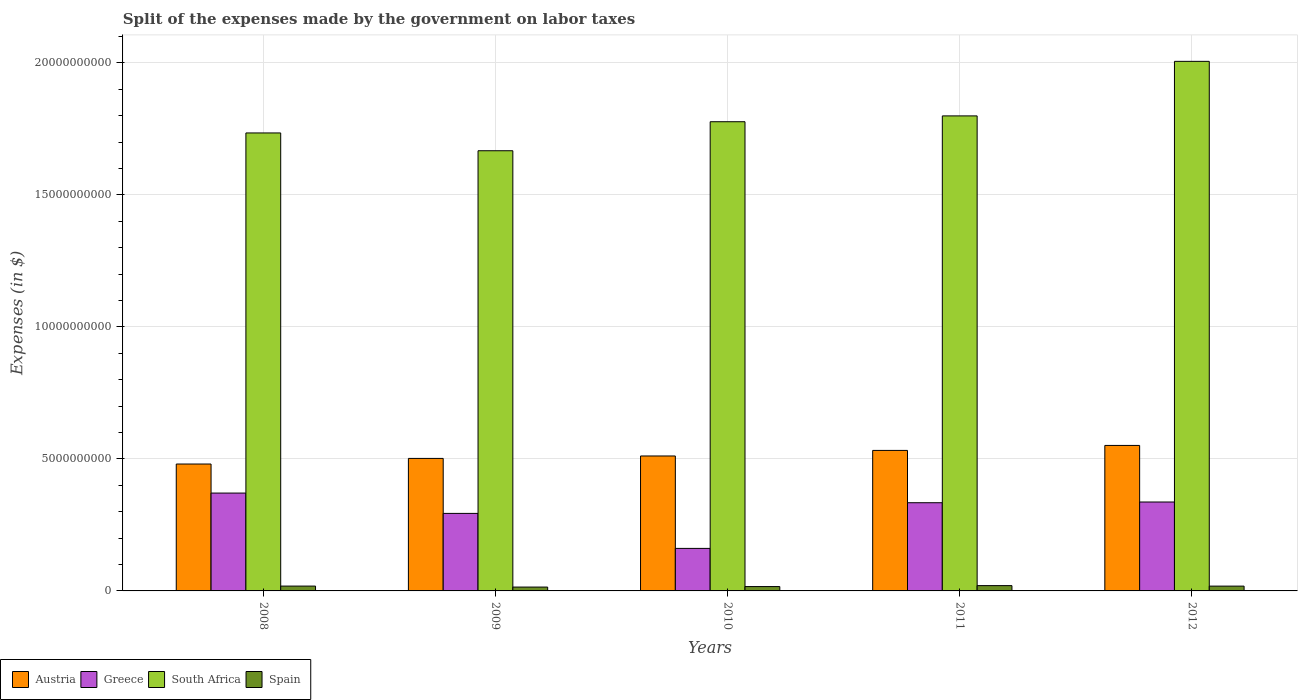How many groups of bars are there?
Keep it short and to the point. 5. Are the number of bars per tick equal to the number of legend labels?
Keep it short and to the point. Yes. Are the number of bars on each tick of the X-axis equal?
Provide a short and direct response. Yes. How many bars are there on the 5th tick from the left?
Provide a short and direct response. 4. How many bars are there on the 1st tick from the right?
Give a very brief answer. 4. What is the label of the 3rd group of bars from the left?
Offer a very short reply. 2010. In how many cases, is the number of bars for a given year not equal to the number of legend labels?
Give a very brief answer. 0. What is the expenses made by the government on labor taxes in Austria in 2009?
Your response must be concise. 5.02e+09. Across all years, what is the maximum expenses made by the government on labor taxes in Spain?
Your answer should be very brief. 2.01e+08. Across all years, what is the minimum expenses made by the government on labor taxes in Greece?
Offer a very short reply. 1.61e+09. In which year was the expenses made by the government on labor taxes in Austria maximum?
Ensure brevity in your answer.  2012. What is the total expenses made by the government on labor taxes in Spain in the graph?
Provide a short and direct response. 8.77e+08. What is the difference between the expenses made by the government on labor taxes in South Africa in 2010 and the expenses made by the government on labor taxes in Greece in 2009?
Offer a very short reply. 1.48e+1. What is the average expenses made by the government on labor taxes in South Africa per year?
Offer a very short reply. 1.80e+1. In the year 2008, what is the difference between the expenses made by the government on labor taxes in Spain and expenses made by the government on labor taxes in Greece?
Your answer should be compact. -3.52e+09. What is the ratio of the expenses made by the government on labor taxes in South Africa in 2009 to that in 2011?
Give a very brief answer. 0.93. Is the expenses made by the government on labor taxes in South Africa in 2011 less than that in 2012?
Your answer should be compact. Yes. What is the difference between the highest and the second highest expenses made by the government on labor taxes in Greece?
Keep it short and to the point. 3.39e+08. What is the difference between the highest and the lowest expenses made by the government on labor taxes in South Africa?
Your answer should be very brief. 3.39e+09. In how many years, is the expenses made by the government on labor taxes in Spain greater than the average expenses made by the government on labor taxes in Spain taken over all years?
Make the answer very short. 3. Is the sum of the expenses made by the government on labor taxes in South Africa in 2008 and 2012 greater than the maximum expenses made by the government on labor taxes in Spain across all years?
Your answer should be very brief. Yes. Is it the case that in every year, the sum of the expenses made by the government on labor taxes in Austria and expenses made by the government on labor taxes in South Africa is greater than the sum of expenses made by the government on labor taxes in Greece and expenses made by the government on labor taxes in Spain?
Offer a terse response. Yes. What does the 2nd bar from the left in 2008 represents?
Provide a short and direct response. Greece. What does the 4th bar from the right in 2010 represents?
Provide a short and direct response. Austria. Is it the case that in every year, the sum of the expenses made by the government on labor taxes in South Africa and expenses made by the government on labor taxes in Spain is greater than the expenses made by the government on labor taxes in Austria?
Make the answer very short. Yes. How many bars are there?
Offer a very short reply. 20. Are the values on the major ticks of Y-axis written in scientific E-notation?
Offer a very short reply. No. Does the graph contain grids?
Provide a succinct answer. Yes. Where does the legend appear in the graph?
Give a very brief answer. Bottom left. How are the legend labels stacked?
Your answer should be very brief. Horizontal. What is the title of the graph?
Give a very brief answer. Split of the expenses made by the government on labor taxes. Does "China" appear as one of the legend labels in the graph?
Offer a terse response. No. What is the label or title of the Y-axis?
Offer a very short reply. Expenses (in $). What is the Expenses (in $) of Austria in 2008?
Keep it short and to the point. 4.81e+09. What is the Expenses (in $) of Greece in 2008?
Offer a terse response. 3.71e+09. What is the Expenses (in $) in South Africa in 2008?
Offer a very short reply. 1.73e+1. What is the Expenses (in $) of Spain in 2008?
Provide a short and direct response. 1.83e+08. What is the Expenses (in $) of Austria in 2009?
Ensure brevity in your answer.  5.02e+09. What is the Expenses (in $) of Greece in 2009?
Give a very brief answer. 2.94e+09. What is the Expenses (in $) in South Africa in 2009?
Offer a terse response. 1.67e+1. What is the Expenses (in $) of Spain in 2009?
Give a very brief answer. 1.46e+08. What is the Expenses (in $) in Austria in 2010?
Ensure brevity in your answer.  5.11e+09. What is the Expenses (in $) of Greece in 2010?
Offer a terse response. 1.61e+09. What is the Expenses (in $) in South Africa in 2010?
Give a very brief answer. 1.78e+1. What is the Expenses (in $) of Spain in 2010?
Give a very brief answer. 1.65e+08. What is the Expenses (in $) of Austria in 2011?
Keep it short and to the point. 5.32e+09. What is the Expenses (in $) of Greece in 2011?
Provide a short and direct response. 3.34e+09. What is the Expenses (in $) of South Africa in 2011?
Your answer should be compact. 1.80e+1. What is the Expenses (in $) in Spain in 2011?
Offer a terse response. 2.01e+08. What is the Expenses (in $) in Austria in 2012?
Provide a succinct answer. 5.51e+09. What is the Expenses (in $) in Greece in 2012?
Offer a very short reply. 3.37e+09. What is the Expenses (in $) in South Africa in 2012?
Make the answer very short. 2.01e+1. What is the Expenses (in $) in Spain in 2012?
Your answer should be compact. 1.82e+08. Across all years, what is the maximum Expenses (in $) in Austria?
Ensure brevity in your answer.  5.51e+09. Across all years, what is the maximum Expenses (in $) in Greece?
Offer a very short reply. 3.71e+09. Across all years, what is the maximum Expenses (in $) of South Africa?
Your response must be concise. 2.01e+1. Across all years, what is the maximum Expenses (in $) of Spain?
Offer a terse response. 2.01e+08. Across all years, what is the minimum Expenses (in $) in Austria?
Your answer should be compact. 4.81e+09. Across all years, what is the minimum Expenses (in $) in Greece?
Make the answer very short. 1.61e+09. Across all years, what is the minimum Expenses (in $) in South Africa?
Make the answer very short. 1.67e+1. Across all years, what is the minimum Expenses (in $) of Spain?
Your answer should be compact. 1.46e+08. What is the total Expenses (in $) in Austria in the graph?
Your answer should be compact. 2.58e+1. What is the total Expenses (in $) in Greece in the graph?
Your response must be concise. 1.50e+1. What is the total Expenses (in $) of South Africa in the graph?
Keep it short and to the point. 8.99e+1. What is the total Expenses (in $) of Spain in the graph?
Ensure brevity in your answer.  8.77e+08. What is the difference between the Expenses (in $) in Austria in 2008 and that in 2009?
Make the answer very short. -2.13e+08. What is the difference between the Expenses (in $) of Greece in 2008 and that in 2009?
Provide a short and direct response. 7.70e+08. What is the difference between the Expenses (in $) in South Africa in 2008 and that in 2009?
Provide a short and direct response. 6.74e+08. What is the difference between the Expenses (in $) of Spain in 2008 and that in 2009?
Make the answer very short. 3.70e+07. What is the difference between the Expenses (in $) in Austria in 2008 and that in 2010?
Your answer should be compact. -3.05e+08. What is the difference between the Expenses (in $) of Greece in 2008 and that in 2010?
Offer a terse response. 2.10e+09. What is the difference between the Expenses (in $) in South Africa in 2008 and that in 2010?
Provide a short and direct response. -4.25e+08. What is the difference between the Expenses (in $) in Spain in 2008 and that in 2010?
Your answer should be compact. 1.80e+07. What is the difference between the Expenses (in $) of Austria in 2008 and that in 2011?
Make the answer very short. -5.16e+08. What is the difference between the Expenses (in $) of Greece in 2008 and that in 2011?
Offer a terse response. 3.66e+08. What is the difference between the Expenses (in $) in South Africa in 2008 and that in 2011?
Provide a short and direct response. -6.46e+08. What is the difference between the Expenses (in $) of Spain in 2008 and that in 2011?
Make the answer very short. -1.80e+07. What is the difference between the Expenses (in $) of Austria in 2008 and that in 2012?
Offer a terse response. -7.04e+08. What is the difference between the Expenses (in $) in Greece in 2008 and that in 2012?
Ensure brevity in your answer.  3.39e+08. What is the difference between the Expenses (in $) in South Africa in 2008 and that in 2012?
Give a very brief answer. -2.71e+09. What is the difference between the Expenses (in $) in Spain in 2008 and that in 2012?
Make the answer very short. 1.00e+06. What is the difference between the Expenses (in $) in Austria in 2009 and that in 2010?
Make the answer very short. -9.23e+07. What is the difference between the Expenses (in $) in Greece in 2009 and that in 2010?
Provide a succinct answer. 1.33e+09. What is the difference between the Expenses (in $) of South Africa in 2009 and that in 2010?
Offer a very short reply. -1.10e+09. What is the difference between the Expenses (in $) of Spain in 2009 and that in 2010?
Provide a short and direct response. -1.90e+07. What is the difference between the Expenses (in $) of Austria in 2009 and that in 2011?
Give a very brief answer. -3.03e+08. What is the difference between the Expenses (in $) of Greece in 2009 and that in 2011?
Give a very brief answer. -4.04e+08. What is the difference between the Expenses (in $) of South Africa in 2009 and that in 2011?
Ensure brevity in your answer.  -1.32e+09. What is the difference between the Expenses (in $) in Spain in 2009 and that in 2011?
Ensure brevity in your answer.  -5.50e+07. What is the difference between the Expenses (in $) of Austria in 2009 and that in 2012?
Offer a terse response. -4.92e+08. What is the difference between the Expenses (in $) of Greece in 2009 and that in 2012?
Offer a very short reply. -4.31e+08. What is the difference between the Expenses (in $) in South Africa in 2009 and that in 2012?
Provide a short and direct response. -3.39e+09. What is the difference between the Expenses (in $) of Spain in 2009 and that in 2012?
Your answer should be compact. -3.60e+07. What is the difference between the Expenses (in $) in Austria in 2010 and that in 2011?
Keep it short and to the point. -2.11e+08. What is the difference between the Expenses (in $) of Greece in 2010 and that in 2011?
Ensure brevity in your answer.  -1.73e+09. What is the difference between the Expenses (in $) of South Africa in 2010 and that in 2011?
Provide a short and direct response. -2.21e+08. What is the difference between the Expenses (in $) of Spain in 2010 and that in 2011?
Offer a terse response. -3.60e+07. What is the difference between the Expenses (in $) in Austria in 2010 and that in 2012?
Give a very brief answer. -3.99e+08. What is the difference between the Expenses (in $) in Greece in 2010 and that in 2012?
Give a very brief answer. -1.76e+09. What is the difference between the Expenses (in $) in South Africa in 2010 and that in 2012?
Offer a very short reply. -2.29e+09. What is the difference between the Expenses (in $) in Spain in 2010 and that in 2012?
Offer a terse response. -1.70e+07. What is the difference between the Expenses (in $) of Austria in 2011 and that in 2012?
Provide a short and direct response. -1.88e+08. What is the difference between the Expenses (in $) in Greece in 2011 and that in 2012?
Provide a short and direct response. -2.70e+07. What is the difference between the Expenses (in $) in South Africa in 2011 and that in 2012?
Provide a short and direct response. -2.07e+09. What is the difference between the Expenses (in $) of Spain in 2011 and that in 2012?
Offer a very short reply. 1.90e+07. What is the difference between the Expenses (in $) of Austria in 2008 and the Expenses (in $) of Greece in 2009?
Offer a terse response. 1.87e+09. What is the difference between the Expenses (in $) of Austria in 2008 and the Expenses (in $) of South Africa in 2009?
Your answer should be compact. -1.19e+1. What is the difference between the Expenses (in $) in Austria in 2008 and the Expenses (in $) in Spain in 2009?
Make the answer very short. 4.66e+09. What is the difference between the Expenses (in $) in Greece in 2008 and the Expenses (in $) in South Africa in 2009?
Provide a succinct answer. -1.30e+1. What is the difference between the Expenses (in $) in Greece in 2008 and the Expenses (in $) in Spain in 2009?
Provide a succinct answer. 3.56e+09. What is the difference between the Expenses (in $) of South Africa in 2008 and the Expenses (in $) of Spain in 2009?
Provide a short and direct response. 1.72e+1. What is the difference between the Expenses (in $) in Austria in 2008 and the Expenses (in $) in Greece in 2010?
Offer a very short reply. 3.20e+09. What is the difference between the Expenses (in $) in Austria in 2008 and the Expenses (in $) in South Africa in 2010?
Your answer should be very brief. -1.30e+1. What is the difference between the Expenses (in $) in Austria in 2008 and the Expenses (in $) in Spain in 2010?
Provide a short and direct response. 4.64e+09. What is the difference between the Expenses (in $) in Greece in 2008 and the Expenses (in $) in South Africa in 2010?
Give a very brief answer. -1.41e+1. What is the difference between the Expenses (in $) in Greece in 2008 and the Expenses (in $) in Spain in 2010?
Your response must be concise. 3.54e+09. What is the difference between the Expenses (in $) in South Africa in 2008 and the Expenses (in $) in Spain in 2010?
Provide a short and direct response. 1.72e+1. What is the difference between the Expenses (in $) of Austria in 2008 and the Expenses (in $) of Greece in 2011?
Keep it short and to the point. 1.47e+09. What is the difference between the Expenses (in $) in Austria in 2008 and the Expenses (in $) in South Africa in 2011?
Keep it short and to the point. -1.32e+1. What is the difference between the Expenses (in $) of Austria in 2008 and the Expenses (in $) of Spain in 2011?
Your answer should be compact. 4.61e+09. What is the difference between the Expenses (in $) in Greece in 2008 and the Expenses (in $) in South Africa in 2011?
Keep it short and to the point. -1.43e+1. What is the difference between the Expenses (in $) in Greece in 2008 and the Expenses (in $) in Spain in 2011?
Offer a very short reply. 3.51e+09. What is the difference between the Expenses (in $) of South Africa in 2008 and the Expenses (in $) of Spain in 2011?
Your answer should be very brief. 1.71e+1. What is the difference between the Expenses (in $) in Austria in 2008 and the Expenses (in $) in Greece in 2012?
Your answer should be compact. 1.44e+09. What is the difference between the Expenses (in $) of Austria in 2008 and the Expenses (in $) of South Africa in 2012?
Offer a terse response. -1.53e+1. What is the difference between the Expenses (in $) in Austria in 2008 and the Expenses (in $) in Spain in 2012?
Your answer should be very brief. 4.62e+09. What is the difference between the Expenses (in $) in Greece in 2008 and the Expenses (in $) in South Africa in 2012?
Provide a short and direct response. -1.64e+1. What is the difference between the Expenses (in $) in Greece in 2008 and the Expenses (in $) in Spain in 2012?
Ensure brevity in your answer.  3.52e+09. What is the difference between the Expenses (in $) of South Africa in 2008 and the Expenses (in $) of Spain in 2012?
Give a very brief answer. 1.72e+1. What is the difference between the Expenses (in $) of Austria in 2009 and the Expenses (in $) of Greece in 2010?
Offer a very short reply. 3.41e+09. What is the difference between the Expenses (in $) in Austria in 2009 and the Expenses (in $) in South Africa in 2010?
Provide a succinct answer. -1.28e+1. What is the difference between the Expenses (in $) of Austria in 2009 and the Expenses (in $) of Spain in 2010?
Keep it short and to the point. 4.85e+09. What is the difference between the Expenses (in $) of Greece in 2009 and the Expenses (in $) of South Africa in 2010?
Your response must be concise. -1.48e+1. What is the difference between the Expenses (in $) in Greece in 2009 and the Expenses (in $) in Spain in 2010?
Give a very brief answer. 2.77e+09. What is the difference between the Expenses (in $) in South Africa in 2009 and the Expenses (in $) in Spain in 2010?
Give a very brief answer. 1.65e+1. What is the difference between the Expenses (in $) of Austria in 2009 and the Expenses (in $) of Greece in 2011?
Your answer should be very brief. 1.68e+09. What is the difference between the Expenses (in $) in Austria in 2009 and the Expenses (in $) in South Africa in 2011?
Give a very brief answer. -1.30e+1. What is the difference between the Expenses (in $) of Austria in 2009 and the Expenses (in $) of Spain in 2011?
Keep it short and to the point. 4.82e+09. What is the difference between the Expenses (in $) in Greece in 2009 and the Expenses (in $) in South Africa in 2011?
Your answer should be very brief. -1.51e+1. What is the difference between the Expenses (in $) in Greece in 2009 and the Expenses (in $) in Spain in 2011?
Offer a very short reply. 2.74e+09. What is the difference between the Expenses (in $) of South Africa in 2009 and the Expenses (in $) of Spain in 2011?
Your answer should be compact. 1.65e+1. What is the difference between the Expenses (in $) in Austria in 2009 and the Expenses (in $) in Greece in 2012?
Your answer should be compact. 1.65e+09. What is the difference between the Expenses (in $) of Austria in 2009 and the Expenses (in $) of South Africa in 2012?
Offer a very short reply. -1.50e+1. What is the difference between the Expenses (in $) of Austria in 2009 and the Expenses (in $) of Spain in 2012?
Offer a terse response. 4.84e+09. What is the difference between the Expenses (in $) in Greece in 2009 and the Expenses (in $) in South Africa in 2012?
Your answer should be compact. -1.71e+1. What is the difference between the Expenses (in $) in Greece in 2009 and the Expenses (in $) in Spain in 2012?
Make the answer very short. 2.76e+09. What is the difference between the Expenses (in $) of South Africa in 2009 and the Expenses (in $) of Spain in 2012?
Give a very brief answer. 1.65e+1. What is the difference between the Expenses (in $) in Austria in 2010 and the Expenses (in $) in Greece in 2011?
Provide a short and direct response. 1.77e+09. What is the difference between the Expenses (in $) in Austria in 2010 and the Expenses (in $) in South Africa in 2011?
Keep it short and to the point. -1.29e+1. What is the difference between the Expenses (in $) in Austria in 2010 and the Expenses (in $) in Spain in 2011?
Provide a succinct answer. 4.91e+09. What is the difference between the Expenses (in $) of Greece in 2010 and the Expenses (in $) of South Africa in 2011?
Your answer should be very brief. -1.64e+1. What is the difference between the Expenses (in $) of Greece in 2010 and the Expenses (in $) of Spain in 2011?
Make the answer very short. 1.41e+09. What is the difference between the Expenses (in $) in South Africa in 2010 and the Expenses (in $) in Spain in 2011?
Give a very brief answer. 1.76e+1. What is the difference between the Expenses (in $) of Austria in 2010 and the Expenses (in $) of Greece in 2012?
Keep it short and to the point. 1.74e+09. What is the difference between the Expenses (in $) in Austria in 2010 and the Expenses (in $) in South Africa in 2012?
Offer a very short reply. -1.49e+1. What is the difference between the Expenses (in $) in Austria in 2010 and the Expenses (in $) in Spain in 2012?
Give a very brief answer. 4.93e+09. What is the difference between the Expenses (in $) in Greece in 2010 and the Expenses (in $) in South Africa in 2012?
Keep it short and to the point. -1.85e+1. What is the difference between the Expenses (in $) of Greece in 2010 and the Expenses (in $) of Spain in 2012?
Provide a short and direct response. 1.43e+09. What is the difference between the Expenses (in $) of South Africa in 2010 and the Expenses (in $) of Spain in 2012?
Your answer should be compact. 1.76e+1. What is the difference between the Expenses (in $) of Austria in 2011 and the Expenses (in $) of Greece in 2012?
Ensure brevity in your answer.  1.95e+09. What is the difference between the Expenses (in $) in Austria in 2011 and the Expenses (in $) in South Africa in 2012?
Give a very brief answer. -1.47e+1. What is the difference between the Expenses (in $) of Austria in 2011 and the Expenses (in $) of Spain in 2012?
Your answer should be very brief. 5.14e+09. What is the difference between the Expenses (in $) in Greece in 2011 and the Expenses (in $) in South Africa in 2012?
Offer a very short reply. -1.67e+1. What is the difference between the Expenses (in $) in Greece in 2011 and the Expenses (in $) in Spain in 2012?
Your answer should be very brief. 3.16e+09. What is the difference between the Expenses (in $) in South Africa in 2011 and the Expenses (in $) in Spain in 2012?
Your response must be concise. 1.78e+1. What is the average Expenses (in $) in Austria per year?
Give a very brief answer. 5.15e+09. What is the average Expenses (in $) in Greece per year?
Give a very brief answer. 2.99e+09. What is the average Expenses (in $) of South Africa per year?
Give a very brief answer. 1.80e+1. What is the average Expenses (in $) of Spain per year?
Provide a succinct answer. 1.75e+08. In the year 2008, what is the difference between the Expenses (in $) in Austria and Expenses (in $) in Greece?
Your answer should be very brief. 1.10e+09. In the year 2008, what is the difference between the Expenses (in $) of Austria and Expenses (in $) of South Africa?
Offer a very short reply. -1.25e+1. In the year 2008, what is the difference between the Expenses (in $) in Austria and Expenses (in $) in Spain?
Offer a very short reply. 4.62e+09. In the year 2008, what is the difference between the Expenses (in $) in Greece and Expenses (in $) in South Africa?
Offer a very short reply. -1.36e+1. In the year 2008, what is the difference between the Expenses (in $) of Greece and Expenses (in $) of Spain?
Ensure brevity in your answer.  3.52e+09. In the year 2008, what is the difference between the Expenses (in $) in South Africa and Expenses (in $) in Spain?
Your answer should be compact. 1.72e+1. In the year 2009, what is the difference between the Expenses (in $) of Austria and Expenses (in $) of Greece?
Your answer should be very brief. 2.08e+09. In the year 2009, what is the difference between the Expenses (in $) in Austria and Expenses (in $) in South Africa?
Give a very brief answer. -1.17e+1. In the year 2009, what is the difference between the Expenses (in $) in Austria and Expenses (in $) in Spain?
Provide a short and direct response. 4.87e+09. In the year 2009, what is the difference between the Expenses (in $) in Greece and Expenses (in $) in South Africa?
Your answer should be compact. -1.37e+1. In the year 2009, what is the difference between the Expenses (in $) in Greece and Expenses (in $) in Spain?
Give a very brief answer. 2.79e+09. In the year 2009, what is the difference between the Expenses (in $) in South Africa and Expenses (in $) in Spain?
Offer a terse response. 1.65e+1. In the year 2010, what is the difference between the Expenses (in $) of Austria and Expenses (in $) of Greece?
Ensure brevity in your answer.  3.50e+09. In the year 2010, what is the difference between the Expenses (in $) of Austria and Expenses (in $) of South Africa?
Provide a short and direct response. -1.27e+1. In the year 2010, what is the difference between the Expenses (in $) in Austria and Expenses (in $) in Spain?
Your response must be concise. 4.95e+09. In the year 2010, what is the difference between the Expenses (in $) in Greece and Expenses (in $) in South Africa?
Your answer should be compact. -1.62e+1. In the year 2010, what is the difference between the Expenses (in $) of Greece and Expenses (in $) of Spain?
Give a very brief answer. 1.45e+09. In the year 2010, what is the difference between the Expenses (in $) in South Africa and Expenses (in $) in Spain?
Make the answer very short. 1.76e+1. In the year 2011, what is the difference between the Expenses (in $) of Austria and Expenses (in $) of Greece?
Your answer should be very brief. 1.98e+09. In the year 2011, what is the difference between the Expenses (in $) in Austria and Expenses (in $) in South Africa?
Give a very brief answer. -1.27e+1. In the year 2011, what is the difference between the Expenses (in $) in Austria and Expenses (in $) in Spain?
Provide a short and direct response. 5.12e+09. In the year 2011, what is the difference between the Expenses (in $) of Greece and Expenses (in $) of South Africa?
Your answer should be very brief. -1.47e+1. In the year 2011, what is the difference between the Expenses (in $) of Greece and Expenses (in $) of Spain?
Provide a succinct answer. 3.14e+09. In the year 2011, what is the difference between the Expenses (in $) in South Africa and Expenses (in $) in Spain?
Ensure brevity in your answer.  1.78e+1. In the year 2012, what is the difference between the Expenses (in $) in Austria and Expenses (in $) in Greece?
Offer a terse response. 2.14e+09. In the year 2012, what is the difference between the Expenses (in $) in Austria and Expenses (in $) in South Africa?
Give a very brief answer. -1.45e+1. In the year 2012, what is the difference between the Expenses (in $) in Austria and Expenses (in $) in Spain?
Give a very brief answer. 5.33e+09. In the year 2012, what is the difference between the Expenses (in $) in Greece and Expenses (in $) in South Africa?
Offer a terse response. -1.67e+1. In the year 2012, what is the difference between the Expenses (in $) in Greece and Expenses (in $) in Spain?
Offer a very short reply. 3.19e+09. In the year 2012, what is the difference between the Expenses (in $) in South Africa and Expenses (in $) in Spain?
Your response must be concise. 1.99e+1. What is the ratio of the Expenses (in $) of Austria in 2008 to that in 2009?
Ensure brevity in your answer.  0.96. What is the ratio of the Expenses (in $) of Greece in 2008 to that in 2009?
Provide a succinct answer. 1.26. What is the ratio of the Expenses (in $) in South Africa in 2008 to that in 2009?
Make the answer very short. 1.04. What is the ratio of the Expenses (in $) of Spain in 2008 to that in 2009?
Offer a terse response. 1.25. What is the ratio of the Expenses (in $) in Austria in 2008 to that in 2010?
Provide a short and direct response. 0.94. What is the ratio of the Expenses (in $) of Greece in 2008 to that in 2010?
Provide a succinct answer. 2.3. What is the ratio of the Expenses (in $) in South Africa in 2008 to that in 2010?
Your response must be concise. 0.98. What is the ratio of the Expenses (in $) in Spain in 2008 to that in 2010?
Offer a terse response. 1.11. What is the ratio of the Expenses (in $) in Austria in 2008 to that in 2011?
Make the answer very short. 0.9. What is the ratio of the Expenses (in $) in Greece in 2008 to that in 2011?
Provide a short and direct response. 1.11. What is the ratio of the Expenses (in $) in South Africa in 2008 to that in 2011?
Ensure brevity in your answer.  0.96. What is the ratio of the Expenses (in $) of Spain in 2008 to that in 2011?
Offer a terse response. 0.91. What is the ratio of the Expenses (in $) of Austria in 2008 to that in 2012?
Keep it short and to the point. 0.87. What is the ratio of the Expenses (in $) of Greece in 2008 to that in 2012?
Make the answer very short. 1.1. What is the ratio of the Expenses (in $) of South Africa in 2008 to that in 2012?
Ensure brevity in your answer.  0.86. What is the ratio of the Expenses (in $) in Austria in 2009 to that in 2010?
Your answer should be very brief. 0.98. What is the ratio of the Expenses (in $) in Greece in 2009 to that in 2010?
Provide a short and direct response. 1.82. What is the ratio of the Expenses (in $) in South Africa in 2009 to that in 2010?
Offer a very short reply. 0.94. What is the ratio of the Expenses (in $) of Spain in 2009 to that in 2010?
Your answer should be compact. 0.88. What is the ratio of the Expenses (in $) of Austria in 2009 to that in 2011?
Keep it short and to the point. 0.94. What is the ratio of the Expenses (in $) of Greece in 2009 to that in 2011?
Offer a very short reply. 0.88. What is the ratio of the Expenses (in $) in South Africa in 2009 to that in 2011?
Your answer should be compact. 0.93. What is the ratio of the Expenses (in $) of Spain in 2009 to that in 2011?
Make the answer very short. 0.73. What is the ratio of the Expenses (in $) in Austria in 2009 to that in 2012?
Offer a terse response. 0.91. What is the ratio of the Expenses (in $) in Greece in 2009 to that in 2012?
Your response must be concise. 0.87. What is the ratio of the Expenses (in $) of South Africa in 2009 to that in 2012?
Ensure brevity in your answer.  0.83. What is the ratio of the Expenses (in $) of Spain in 2009 to that in 2012?
Make the answer very short. 0.8. What is the ratio of the Expenses (in $) of Austria in 2010 to that in 2011?
Ensure brevity in your answer.  0.96. What is the ratio of the Expenses (in $) of Greece in 2010 to that in 2011?
Provide a short and direct response. 0.48. What is the ratio of the Expenses (in $) of Spain in 2010 to that in 2011?
Provide a short and direct response. 0.82. What is the ratio of the Expenses (in $) of Austria in 2010 to that in 2012?
Keep it short and to the point. 0.93. What is the ratio of the Expenses (in $) in Greece in 2010 to that in 2012?
Provide a succinct answer. 0.48. What is the ratio of the Expenses (in $) of South Africa in 2010 to that in 2012?
Your response must be concise. 0.89. What is the ratio of the Expenses (in $) in Spain in 2010 to that in 2012?
Ensure brevity in your answer.  0.91. What is the ratio of the Expenses (in $) of Austria in 2011 to that in 2012?
Your answer should be very brief. 0.97. What is the ratio of the Expenses (in $) of South Africa in 2011 to that in 2012?
Your response must be concise. 0.9. What is the ratio of the Expenses (in $) in Spain in 2011 to that in 2012?
Your answer should be compact. 1.1. What is the difference between the highest and the second highest Expenses (in $) in Austria?
Your answer should be very brief. 1.88e+08. What is the difference between the highest and the second highest Expenses (in $) of Greece?
Ensure brevity in your answer.  3.39e+08. What is the difference between the highest and the second highest Expenses (in $) of South Africa?
Your answer should be very brief. 2.07e+09. What is the difference between the highest and the second highest Expenses (in $) in Spain?
Your response must be concise. 1.80e+07. What is the difference between the highest and the lowest Expenses (in $) of Austria?
Your answer should be very brief. 7.04e+08. What is the difference between the highest and the lowest Expenses (in $) in Greece?
Offer a terse response. 2.10e+09. What is the difference between the highest and the lowest Expenses (in $) in South Africa?
Provide a succinct answer. 3.39e+09. What is the difference between the highest and the lowest Expenses (in $) of Spain?
Offer a terse response. 5.50e+07. 